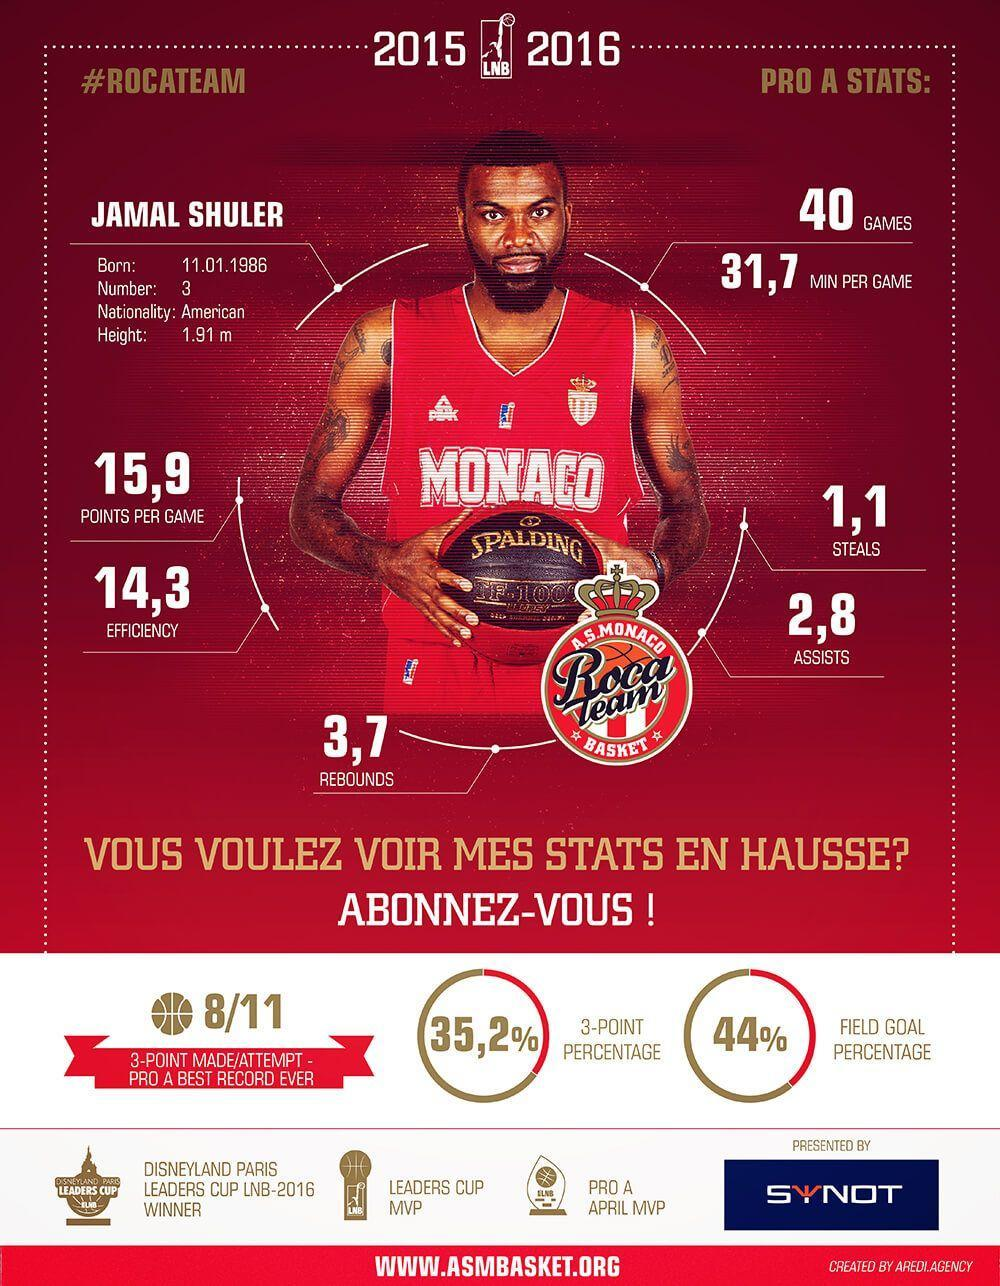Which club jersey is the player Jamal Shuler wearing?
Answer the question with a short phrase. AS Monaco Basket What is the points per game scored by Shuler, 31.7, 15.9, or 1.1? 15.9 What is the number of assists scored by Shuler, 14.3, 3.7, or 2.8? 2.8 Which basketball team does Jamal Shuler belong to? Roca Team 